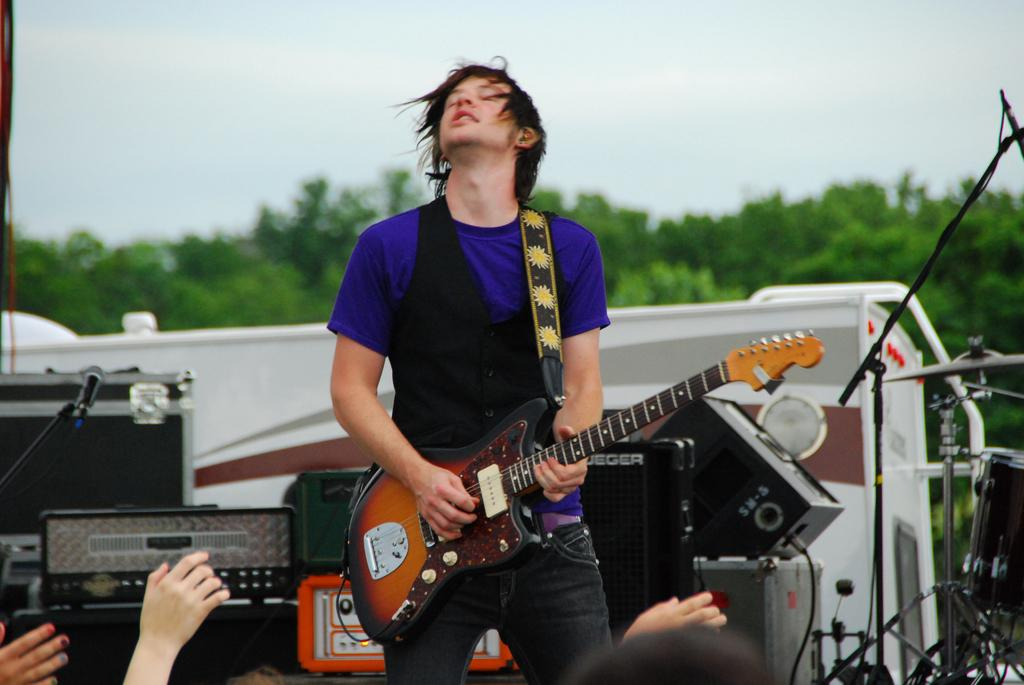What is the man in the image doing? The man is playing a guitar in the image. What other objects are related to music in the image? There are musical instruments in the image. What can be seen in the background of the image? There are trees and the sky visible in the background of the image. How many sheep can be seen grazing in the image? There are no sheep present in the image. What part of the man's body is injured in the image? There is no indication of an injury or any body part in the image. 